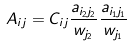Convert formula to latex. <formula><loc_0><loc_0><loc_500><loc_500>A _ { i j } = C _ { i j } \frac { a _ { i _ { 2 } j _ { 2 } } } { w _ { j _ { 2 } } } \frac { a _ { i _ { 1 } j _ { 1 } } } { w _ { j _ { 1 } } }</formula> 